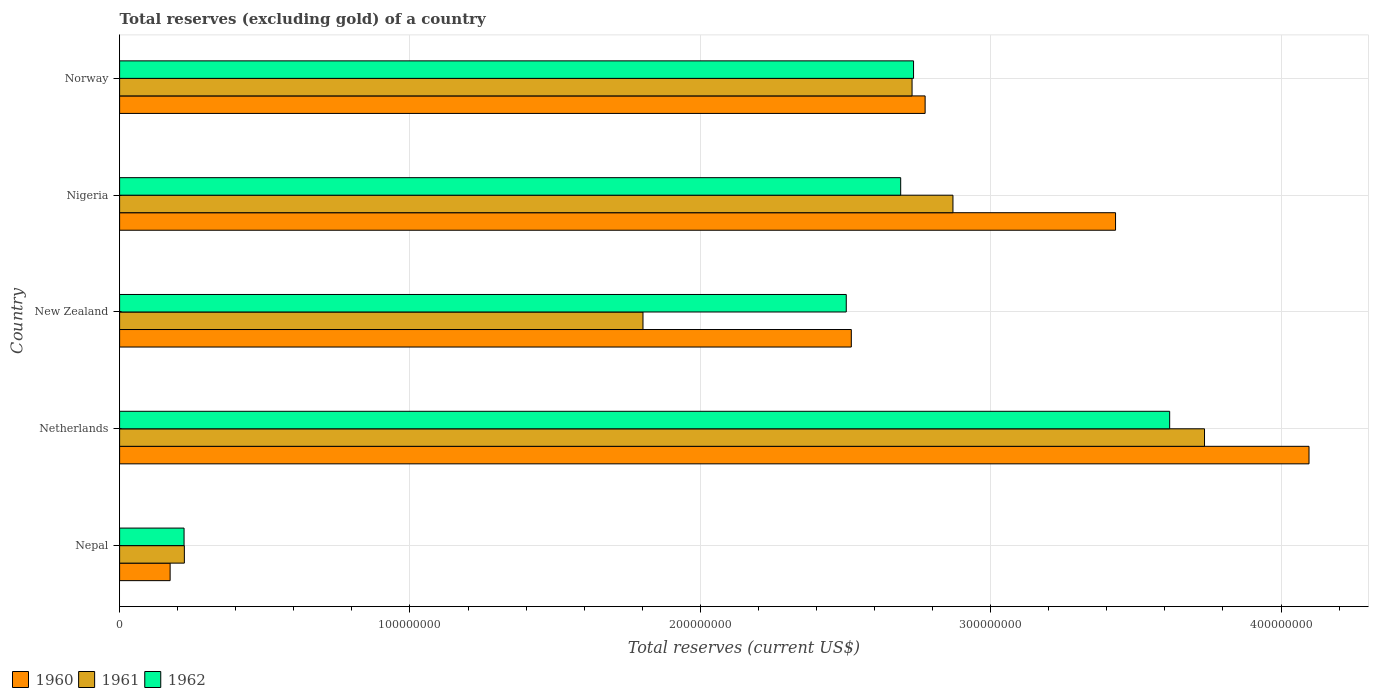How many different coloured bars are there?
Make the answer very short. 3. How many groups of bars are there?
Your answer should be very brief. 5. Are the number of bars per tick equal to the number of legend labels?
Make the answer very short. Yes. How many bars are there on the 3rd tick from the bottom?
Provide a short and direct response. 3. What is the total reserves (excluding gold) in 1962 in Netherlands?
Offer a very short reply. 3.62e+08. Across all countries, what is the maximum total reserves (excluding gold) in 1960?
Offer a terse response. 4.10e+08. Across all countries, what is the minimum total reserves (excluding gold) in 1960?
Keep it short and to the point. 1.74e+07. In which country was the total reserves (excluding gold) in 1961 maximum?
Offer a terse response. Netherlands. In which country was the total reserves (excluding gold) in 1961 minimum?
Your answer should be compact. Nepal. What is the total total reserves (excluding gold) in 1961 in the graph?
Your answer should be very brief. 1.14e+09. What is the difference between the total reserves (excluding gold) in 1962 in Nepal and that in Norway?
Your response must be concise. -2.51e+08. What is the difference between the total reserves (excluding gold) in 1960 in New Zealand and the total reserves (excluding gold) in 1962 in Nigeria?
Provide a succinct answer. -1.70e+07. What is the average total reserves (excluding gold) in 1961 per country?
Your response must be concise. 2.27e+08. What is the difference between the total reserves (excluding gold) in 1961 and total reserves (excluding gold) in 1962 in New Zealand?
Provide a short and direct response. -7.00e+07. In how many countries, is the total reserves (excluding gold) in 1961 greater than 160000000 US$?
Your answer should be very brief. 4. What is the ratio of the total reserves (excluding gold) in 1961 in Netherlands to that in New Zealand?
Keep it short and to the point. 2.07. Is the difference between the total reserves (excluding gold) in 1961 in New Zealand and Norway greater than the difference between the total reserves (excluding gold) in 1962 in New Zealand and Norway?
Ensure brevity in your answer.  No. What is the difference between the highest and the second highest total reserves (excluding gold) in 1961?
Provide a short and direct response. 8.66e+07. What is the difference between the highest and the lowest total reserves (excluding gold) in 1962?
Provide a succinct answer. 3.39e+08. What does the 3rd bar from the top in New Zealand represents?
Your response must be concise. 1960. Is it the case that in every country, the sum of the total reserves (excluding gold) in 1962 and total reserves (excluding gold) in 1961 is greater than the total reserves (excluding gold) in 1960?
Provide a short and direct response. Yes. How many bars are there?
Provide a succinct answer. 15. Are all the bars in the graph horizontal?
Ensure brevity in your answer.  Yes. What is the difference between two consecutive major ticks on the X-axis?
Ensure brevity in your answer.  1.00e+08. Does the graph contain any zero values?
Your answer should be compact. No. Does the graph contain grids?
Your answer should be compact. Yes. How many legend labels are there?
Give a very brief answer. 3. How are the legend labels stacked?
Offer a terse response. Horizontal. What is the title of the graph?
Make the answer very short. Total reserves (excluding gold) of a country. What is the label or title of the X-axis?
Ensure brevity in your answer.  Total reserves (current US$). What is the label or title of the Y-axis?
Keep it short and to the point. Country. What is the Total reserves (current US$) of 1960 in Nepal?
Provide a succinct answer. 1.74e+07. What is the Total reserves (current US$) in 1961 in Nepal?
Provide a short and direct response. 2.23e+07. What is the Total reserves (current US$) in 1962 in Nepal?
Offer a very short reply. 2.22e+07. What is the Total reserves (current US$) of 1960 in Netherlands?
Offer a terse response. 4.10e+08. What is the Total reserves (current US$) of 1961 in Netherlands?
Keep it short and to the point. 3.74e+08. What is the Total reserves (current US$) of 1962 in Netherlands?
Keep it short and to the point. 3.62e+08. What is the Total reserves (current US$) in 1960 in New Zealand?
Ensure brevity in your answer.  2.52e+08. What is the Total reserves (current US$) of 1961 in New Zealand?
Your answer should be compact. 1.80e+08. What is the Total reserves (current US$) of 1962 in New Zealand?
Ensure brevity in your answer.  2.50e+08. What is the Total reserves (current US$) in 1960 in Nigeria?
Offer a very short reply. 3.43e+08. What is the Total reserves (current US$) of 1961 in Nigeria?
Make the answer very short. 2.87e+08. What is the Total reserves (current US$) in 1962 in Nigeria?
Offer a very short reply. 2.69e+08. What is the Total reserves (current US$) in 1960 in Norway?
Your answer should be compact. 2.77e+08. What is the Total reserves (current US$) in 1961 in Norway?
Provide a short and direct response. 2.73e+08. What is the Total reserves (current US$) of 1962 in Norway?
Offer a terse response. 2.73e+08. Across all countries, what is the maximum Total reserves (current US$) of 1960?
Your answer should be compact. 4.10e+08. Across all countries, what is the maximum Total reserves (current US$) in 1961?
Provide a succinct answer. 3.74e+08. Across all countries, what is the maximum Total reserves (current US$) in 1962?
Keep it short and to the point. 3.62e+08. Across all countries, what is the minimum Total reserves (current US$) of 1960?
Your answer should be very brief. 1.74e+07. Across all countries, what is the minimum Total reserves (current US$) in 1961?
Offer a terse response. 2.23e+07. Across all countries, what is the minimum Total reserves (current US$) in 1962?
Ensure brevity in your answer.  2.22e+07. What is the total Total reserves (current US$) in 1960 in the graph?
Your answer should be compact. 1.30e+09. What is the total Total reserves (current US$) of 1961 in the graph?
Your response must be concise. 1.14e+09. What is the total Total reserves (current US$) of 1962 in the graph?
Make the answer very short. 1.18e+09. What is the difference between the Total reserves (current US$) in 1960 in Nepal and that in Netherlands?
Offer a terse response. -3.92e+08. What is the difference between the Total reserves (current US$) of 1961 in Nepal and that in Netherlands?
Your response must be concise. -3.51e+08. What is the difference between the Total reserves (current US$) of 1962 in Nepal and that in Netherlands?
Make the answer very short. -3.39e+08. What is the difference between the Total reserves (current US$) of 1960 in Nepal and that in New Zealand?
Offer a very short reply. -2.35e+08. What is the difference between the Total reserves (current US$) of 1961 in Nepal and that in New Zealand?
Provide a succinct answer. -1.58e+08. What is the difference between the Total reserves (current US$) in 1962 in Nepal and that in New Zealand?
Your answer should be compact. -2.28e+08. What is the difference between the Total reserves (current US$) in 1960 in Nepal and that in Nigeria?
Your answer should be very brief. -3.26e+08. What is the difference between the Total reserves (current US$) in 1961 in Nepal and that in Nigeria?
Make the answer very short. -2.65e+08. What is the difference between the Total reserves (current US$) of 1962 in Nepal and that in Nigeria?
Give a very brief answer. -2.47e+08. What is the difference between the Total reserves (current US$) of 1960 in Nepal and that in Norway?
Your answer should be compact. -2.60e+08. What is the difference between the Total reserves (current US$) of 1961 in Nepal and that in Norway?
Provide a short and direct response. -2.51e+08. What is the difference between the Total reserves (current US$) in 1962 in Nepal and that in Norway?
Your answer should be very brief. -2.51e+08. What is the difference between the Total reserves (current US$) of 1960 in Netherlands and that in New Zealand?
Make the answer very short. 1.58e+08. What is the difference between the Total reserves (current US$) in 1961 in Netherlands and that in New Zealand?
Give a very brief answer. 1.93e+08. What is the difference between the Total reserves (current US$) in 1962 in Netherlands and that in New Zealand?
Your answer should be compact. 1.11e+08. What is the difference between the Total reserves (current US$) in 1960 in Netherlands and that in Nigeria?
Your answer should be compact. 6.66e+07. What is the difference between the Total reserves (current US$) of 1961 in Netherlands and that in Nigeria?
Make the answer very short. 8.66e+07. What is the difference between the Total reserves (current US$) of 1962 in Netherlands and that in Nigeria?
Make the answer very short. 9.26e+07. What is the difference between the Total reserves (current US$) in 1960 in Netherlands and that in Norway?
Your answer should be compact. 1.32e+08. What is the difference between the Total reserves (current US$) of 1961 in Netherlands and that in Norway?
Your answer should be compact. 1.01e+08. What is the difference between the Total reserves (current US$) of 1962 in Netherlands and that in Norway?
Keep it short and to the point. 8.82e+07. What is the difference between the Total reserves (current US$) of 1960 in New Zealand and that in Nigeria?
Provide a short and direct response. -9.10e+07. What is the difference between the Total reserves (current US$) in 1961 in New Zealand and that in Nigeria?
Offer a very short reply. -1.07e+08. What is the difference between the Total reserves (current US$) in 1962 in New Zealand and that in Nigeria?
Provide a succinct answer. -1.87e+07. What is the difference between the Total reserves (current US$) of 1960 in New Zealand and that in Norway?
Ensure brevity in your answer.  -2.54e+07. What is the difference between the Total reserves (current US$) in 1961 in New Zealand and that in Norway?
Offer a very short reply. -9.27e+07. What is the difference between the Total reserves (current US$) in 1962 in New Zealand and that in Norway?
Provide a succinct answer. -2.32e+07. What is the difference between the Total reserves (current US$) in 1960 in Nigeria and that in Norway?
Your answer should be compact. 6.56e+07. What is the difference between the Total reserves (current US$) of 1961 in Nigeria and that in Norway?
Keep it short and to the point. 1.41e+07. What is the difference between the Total reserves (current US$) in 1962 in Nigeria and that in Norway?
Your response must be concise. -4.43e+06. What is the difference between the Total reserves (current US$) of 1960 in Nepal and the Total reserves (current US$) of 1961 in Netherlands?
Your answer should be very brief. -3.56e+08. What is the difference between the Total reserves (current US$) of 1960 in Nepal and the Total reserves (current US$) of 1962 in Netherlands?
Provide a short and direct response. -3.44e+08. What is the difference between the Total reserves (current US$) in 1961 in Nepal and the Total reserves (current US$) in 1962 in Netherlands?
Give a very brief answer. -3.39e+08. What is the difference between the Total reserves (current US$) in 1960 in Nepal and the Total reserves (current US$) in 1961 in New Zealand?
Provide a succinct answer. -1.63e+08. What is the difference between the Total reserves (current US$) of 1960 in Nepal and the Total reserves (current US$) of 1962 in New Zealand?
Provide a short and direct response. -2.33e+08. What is the difference between the Total reserves (current US$) of 1961 in Nepal and the Total reserves (current US$) of 1962 in New Zealand?
Provide a succinct answer. -2.28e+08. What is the difference between the Total reserves (current US$) of 1960 in Nepal and the Total reserves (current US$) of 1961 in Nigeria?
Offer a very short reply. -2.70e+08. What is the difference between the Total reserves (current US$) of 1960 in Nepal and the Total reserves (current US$) of 1962 in Nigeria?
Your response must be concise. -2.52e+08. What is the difference between the Total reserves (current US$) of 1961 in Nepal and the Total reserves (current US$) of 1962 in Nigeria?
Your answer should be compact. -2.47e+08. What is the difference between the Total reserves (current US$) in 1960 in Nepal and the Total reserves (current US$) in 1961 in Norway?
Offer a terse response. -2.56e+08. What is the difference between the Total reserves (current US$) of 1960 in Nepal and the Total reserves (current US$) of 1962 in Norway?
Offer a terse response. -2.56e+08. What is the difference between the Total reserves (current US$) in 1961 in Nepal and the Total reserves (current US$) in 1962 in Norway?
Keep it short and to the point. -2.51e+08. What is the difference between the Total reserves (current US$) in 1960 in Netherlands and the Total reserves (current US$) in 1961 in New Zealand?
Your response must be concise. 2.29e+08. What is the difference between the Total reserves (current US$) of 1960 in Netherlands and the Total reserves (current US$) of 1962 in New Zealand?
Provide a succinct answer. 1.59e+08. What is the difference between the Total reserves (current US$) in 1961 in Netherlands and the Total reserves (current US$) in 1962 in New Zealand?
Make the answer very short. 1.23e+08. What is the difference between the Total reserves (current US$) in 1960 in Netherlands and the Total reserves (current US$) in 1961 in Nigeria?
Your answer should be very brief. 1.23e+08. What is the difference between the Total reserves (current US$) of 1960 in Netherlands and the Total reserves (current US$) of 1962 in Nigeria?
Offer a very short reply. 1.41e+08. What is the difference between the Total reserves (current US$) in 1961 in Netherlands and the Total reserves (current US$) in 1962 in Nigeria?
Your response must be concise. 1.05e+08. What is the difference between the Total reserves (current US$) in 1960 in Netherlands and the Total reserves (current US$) in 1961 in Norway?
Offer a very short reply. 1.37e+08. What is the difference between the Total reserves (current US$) of 1960 in Netherlands and the Total reserves (current US$) of 1962 in Norway?
Ensure brevity in your answer.  1.36e+08. What is the difference between the Total reserves (current US$) of 1961 in Netherlands and the Total reserves (current US$) of 1962 in Norway?
Your answer should be very brief. 1.00e+08. What is the difference between the Total reserves (current US$) in 1960 in New Zealand and the Total reserves (current US$) in 1961 in Nigeria?
Your answer should be very brief. -3.50e+07. What is the difference between the Total reserves (current US$) of 1960 in New Zealand and the Total reserves (current US$) of 1962 in Nigeria?
Provide a short and direct response. -1.70e+07. What is the difference between the Total reserves (current US$) in 1961 in New Zealand and the Total reserves (current US$) in 1962 in Nigeria?
Your response must be concise. -8.88e+07. What is the difference between the Total reserves (current US$) in 1960 in New Zealand and the Total reserves (current US$) in 1961 in Norway?
Your response must be concise. -2.09e+07. What is the difference between the Total reserves (current US$) in 1960 in New Zealand and the Total reserves (current US$) in 1962 in Norway?
Your answer should be very brief. -2.14e+07. What is the difference between the Total reserves (current US$) of 1961 in New Zealand and the Total reserves (current US$) of 1962 in Norway?
Make the answer very short. -9.32e+07. What is the difference between the Total reserves (current US$) of 1960 in Nigeria and the Total reserves (current US$) of 1961 in Norway?
Provide a short and direct response. 7.01e+07. What is the difference between the Total reserves (current US$) in 1960 in Nigeria and the Total reserves (current US$) in 1962 in Norway?
Keep it short and to the point. 6.96e+07. What is the difference between the Total reserves (current US$) of 1961 in Nigeria and the Total reserves (current US$) of 1962 in Norway?
Keep it short and to the point. 1.36e+07. What is the average Total reserves (current US$) of 1960 per country?
Ensure brevity in your answer.  2.60e+08. What is the average Total reserves (current US$) in 1961 per country?
Give a very brief answer. 2.27e+08. What is the average Total reserves (current US$) of 1962 per country?
Offer a terse response. 2.35e+08. What is the difference between the Total reserves (current US$) of 1960 and Total reserves (current US$) of 1961 in Nepal?
Provide a succinct answer. -4.90e+06. What is the difference between the Total reserves (current US$) of 1960 and Total reserves (current US$) of 1962 in Nepal?
Keep it short and to the point. -4.80e+06. What is the difference between the Total reserves (current US$) of 1961 and Total reserves (current US$) of 1962 in Nepal?
Provide a short and direct response. 1.00e+05. What is the difference between the Total reserves (current US$) in 1960 and Total reserves (current US$) in 1961 in Netherlands?
Your answer should be compact. 3.60e+07. What is the difference between the Total reserves (current US$) of 1960 and Total reserves (current US$) of 1962 in Netherlands?
Provide a succinct answer. 4.80e+07. What is the difference between the Total reserves (current US$) of 1961 and Total reserves (current US$) of 1962 in Netherlands?
Your answer should be very brief. 1.20e+07. What is the difference between the Total reserves (current US$) in 1960 and Total reserves (current US$) in 1961 in New Zealand?
Make the answer very short. 7.18e+07. What is the difference between the Total reserves (current US$) of 1960 and Total reserves (current US$) of 1962 in New Zealand?
Offer a terse response. 1.74e+06. What is the difference between the Total reserves (current US$) of 1961 and Total reserves (current US$) of 1962 in New Zealand?
Ensure brevity in your answer.  -7.00e+07. What is the difference between the Total reserves (current US$) of 1960 and Total reserves (current US$) of 1961 in Nigeria?
Your response must be concise. 5.60e+07. What is the difference between the Total reserves (current US$) in 1960 and Total reserves (current US$) in 1962 in Nigeria?
Offer a very short reply. 7.40e+07. What is the difference between the Total reserves (current US$) in 1961 and Total reserves (current US$) in 1962 in Nigeria?
Your answer should be compact. 1.80e+07. What is the difference between the Total reserves (current US$) in 1960 and Total reserves (current US$) in 1961 in Norway?
Offer a terse response. 4.50e+06. What is the difference between the Total reserves (current US$) of 1960 and Total reserves (current US$) of 1962 in Norway?
Your answer should be very brief. 3.99e+06. What is the difference between the Total reserves (current US$) of 1961 and Total reserves (current US$) of 1962 in Norway?
Provide a succinct answer. -5.10e+05. What is the ratio of the Total reserves (current US$) in 1960 in Nepal to that in Netherlands?
Make the answer very short. 0.04. What is the ratio of the Total reserves (current US$) in 1961 in Nepal to that in Netherlands?
Provide a succinct answer. 0.06. What is the ratio of the Total reserves (current US$) in 1962 in Nepal to that in Netherlands?
Provide a short and direct response. 0.06. What is the ratio of the Total reserves (current US$) of 1960 in Nepal to that in New Zealand?
Offer a very short reply. 0.07. What is the ratio of the Total reserves (current US$) in 1961 in Nepal to that in New Zealand?
Provide a short and direct response. 0.12. What is the ratio of the Total reserves (current US$) of 1962 in Nepal to that in New Zealand?
Ensure brevity in your answer.  0.09. What is the ratio of the Total reserves (current US$) in 1960 in Nepal to that in Nigeria?
Provide a short and direct response. 0.05. What is the ratio of the Total reserves (current US$) of 1961 in Nepal to that in Nigeria?
Make the answer very short. 0.08. What is the ratio of the Total reserves (current US$) in 1962 in Nepal to that in Nigeria?
Offer a very short reply. 0.08. What is the ratio of the Total reserves (current US$) in 1960 in Nepal to that in Norway?
Make the answer very short. 0.06. What is the ratio of the Total reserves (current US$) of 1961 in Nepal to that in Norway?
Offer a very short reply. 0.08. What is the ratio of the Total reserves (current US$) in 1962 in Nepal to that in Norway?
Keep it short and to the point. 0.08. What is the ratio of the Total reserves (current US$) of 1960 in Netherlands to that in New Zealand?
Your answer should be compact. 1.63. What is the ratio of the Total reserves (current US$) in 1961 in Netherlands to that in New Zealand?
Ensure brevity in your answer.  2.07. What is the ratio of the Total reserves (current US$) of 1962 in Netherlands to that in New Zealand?
Provide a short and direct response. 1.45. What is the ratio of the Total reserves (current US$) in 1960 in Netherlands to that in Nigeria?
Ensure brevity in your answer.  1.19. What is the ratio of the Total reserves (current US$) in 1961 in Netherlands to that in Nigeria?
Ensure brevity in your answer.  1.3. What is the ratio of the Total reserves (current US$) of 1962 in Netherlands to that in Nigeria?
Give a very brief answer. 1.34. What is the ratio of the Total reserves (current US$) of 1960 in Netherlands to that in Norway?
Provide a succinct answer. 1.48. What is the ratio of the Total reserves (current US$) in 1961 in Netherlands to that in Norway?
Your response must be concise. 1.37. What is the ratio of the Total reserves (current US$) of 1962 in Netherlands to that in Norway?
Make the answer very short. 1.32. What is the ratio of the Total reserves (current US$) in 1960 in New Zealand to that in Nigeria?
Give a very brief answer. 0.73. What is the ratio of the Total reserves (current US$) of 1961 in New Zealand to that in Nigeria?
Offer a very short reply. 0.63. What is the ratio of the Total reserves (current US$) in 1962 in New Zealand to that in Nigeria?
Your answer should be compact. 0.93. What is the ratio of the Total reserves (current US$) of 1960 in New Zealand to that in Norway?
Make the answer very short. 0.91. What is the ratio of the Total reserves (current US$) in 1961 in New Zealand to that in Norway?
Your response must be concise. 0.66. What is the ratio of the Total reserves (current US$) of 1962 in New Zealand to that in Norway?
Keep it short and to the point. 0.92. What is the ratio of the Total reserves (current US$) in 1960 in Nigeria to that in Norway?
Ensure brevity in your answer.  1.24. What is the ratio of the Total reserves (current US$) of 1961 in Nigeria to that in Norway?
Ensure brevity in your answer.  1.05. What is the ratio of the Total reserves (current US$) in 1962 in Nigeria to that in Norway?
Offer a very short reply. 0.98. What is the difference between the highest and the second highest Total reserves (current US$) of 1960?
Provide a short and direct response. 6.66e+07. What is the difference between the highest and the second highest Total reserves (current US$) of 1961?
Your response must be concise. 8.66e+07. What is the difference between the highest and the second highest Total reserves (current US$) in 1962?
Your response must be concise. 8.82e+07. What is the difference between the highest and the lowest Total reserves (current US$) in 1960?
Provide a short and direct response. 3.92e+08. What is the difference between the highest and the lowest Total reserves (current US$) in 1961?
Offer a terse response. 3.51e+08. What is the difference between the highest and the lowest Total reserves (current US$) in 1962?
Provide a short and direct response. 3.39e+08. 